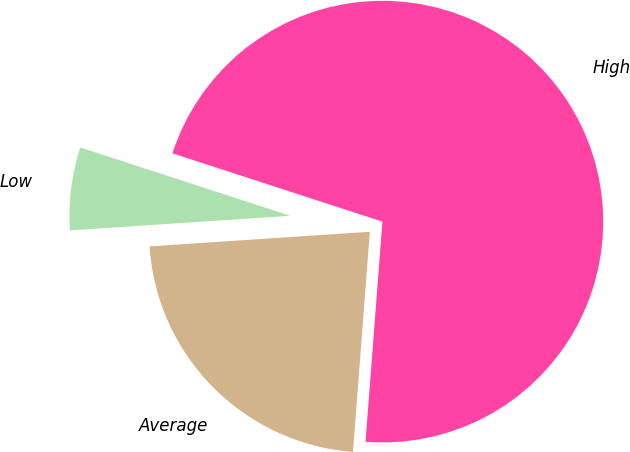Convert chart. <chart><loc_0><loc_0><loc_500><loc_500><pie_chart><fcel>Average<fcel>High<fcel>Low<nl><fcel>22.73%<fcel>71.21%<fcel>6.06%<nl></chart> 